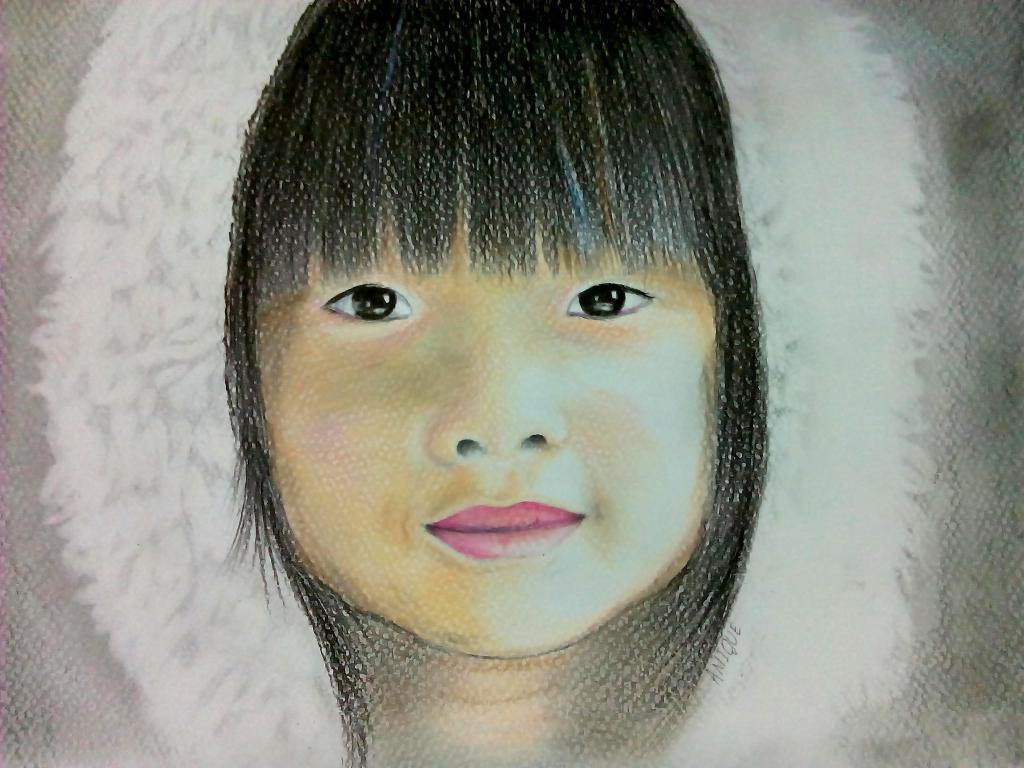What is the main subject of the painting in the image? The main subject of the painting in the image is a child's face. What expression does the child in the painting have? The child in the painting is smiling. What type of clothing is the child in the painting wearing? The child in the painting is wearing a fur coat. What type of fuel is the child's brother using to power their spaceship in the image? There is no child's brother or spaceship present in the image; it features a painting of a child's face. 